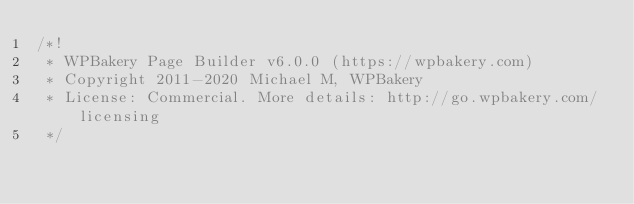Convert code to text. <code><loc_0><loc_0><loc_500><loc_500><_CSS_>/*!
 * WPBakery Page Builder v6.0.0 (https://wpbakery.com)
 * Copyright 2011-2020 Michael M, WPBakery
 * License: Commercial. More details: http://go.wpbakery.com/licensing
 */
</code> 